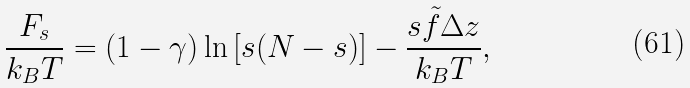Convert formula to latex. <formula><loc_0><loc_0><loc_500><loc_500>\frac { F _ { s } } { k _ { B } T } = ( 1 - \gamma ) \ln \left [ s ( N - s ) \right ] - \frac { s \tilde { f } \Delta z } { k _ { B } T } ,</formula> 